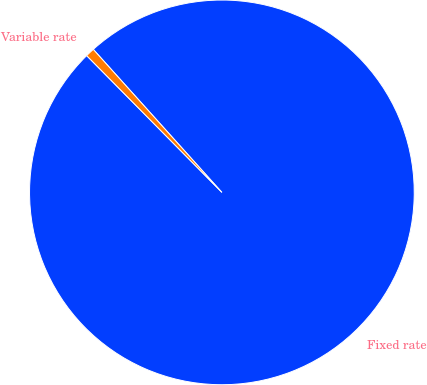Convert chart to OTSL. <chart><loc_0><loc_0><loc_500><loc_500><pie_chart><fcel>Fixed rate<fcel>Variable rate<nl><fcel>99.25%<fcel>0.75%<nl></chart> 